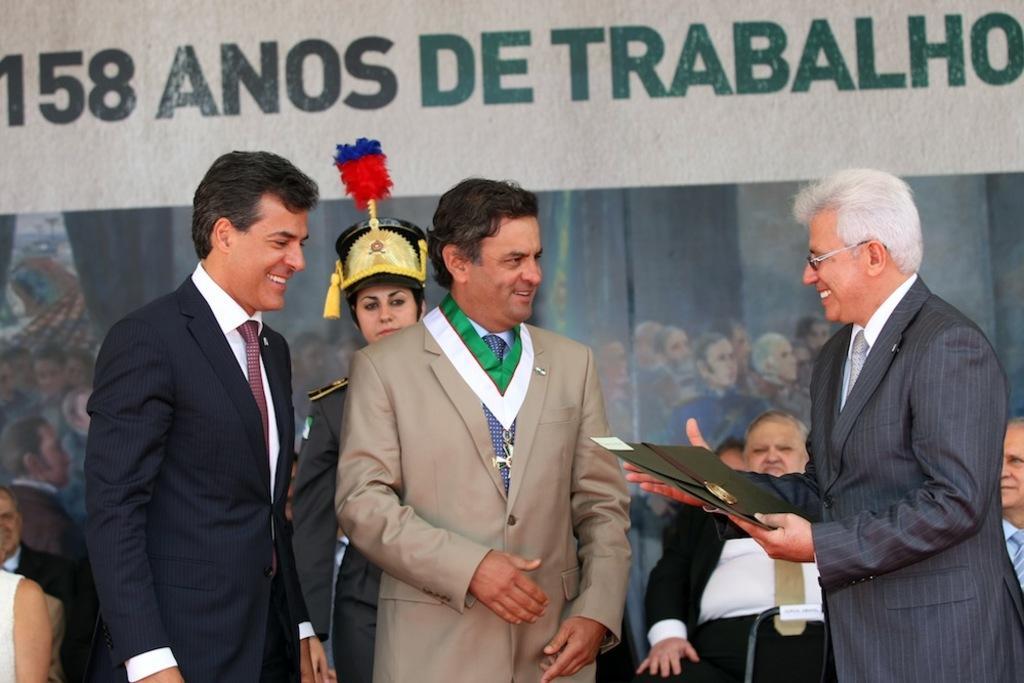Can you describe this image briefly? In this image we can see people and on the right side of the image we can see a person holding an object with his hands. In the background we can see pictures of people and something is written on a hoarding. 